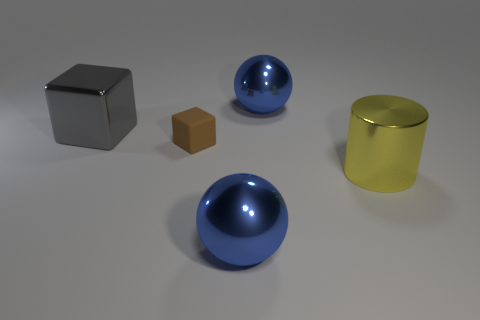Is there any other thing that is the same size as the matte object?
Give a very brief answer. No. What size is the shiny sphere in front of the large ball behind the brown object?
Offer a very short reply. Large. Are there an equal number of large spheres that are behind the small brown thing and big blue metal objects that are in front of the big cube?
Provide a succinct answer. Yes. There is a blue thing that is in front of the metal cylinder; are there any tiny blocks in front of it?
Give a very brief answer. No. The gray thing that is the same material as the big cylinder is what shape?
Provide a succinct answer. Cube. Are there any other things that have the same color as the cylinder?
Offer a terse response. No. There is a gray object that is left of the metallic ball that is behind the shiny cube; what is it made of?
Your answer should be very brief. Metal. Are there any big shiny objects of the same shape as the tiny matte object?
Provide a succinct answer. Yes. What number of other things are the same shape as the tiny brown rubber thing?
Offer a terse response. 1. What shape is the metallic object that is both to the left of the big yellow cylinder and in front of the large gray object?
Ensure brevity in your answer.  Sphere. 